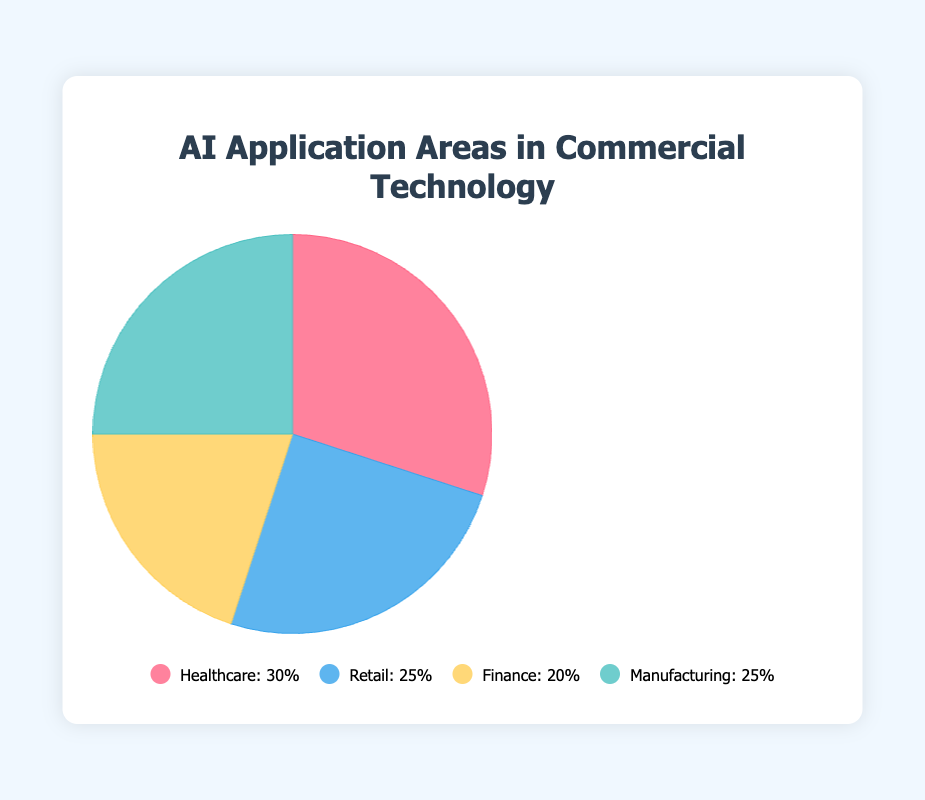Which AI application area has the highest percentage? The Healthcare category has the highest percentage at 30%. This is identified by looking at the label with the highest percentage in the pie chart.
Answer: Healthcare Which two AI application areas have an equal percentage? The Retail and Manufacturing categories both have a percentage of 25%. This can be identified by visually comparing the sizes of the segments in the pie chart and their corresponding percentages.
Answer: Retail and Manufacturing What is the difference in percentage between Healthcare and Finance? The Healthcare category has 30%, and the Finance category has 20%. The difference between these two values is calculated as 30% - 20% = 10%.
Answer: 10% What are the top two categories in terms of percentage? The top two categories are Healthcare with 30% and both Retail and Manufacturing with 25%. To identify the top two, look for the largest segments and their percentages.
Answer: Healthcare and Retail/Manufacturing What is the average percentage of all AI application areas? The percentages are 30% (Healthcare), 25% (Retail), 20% (Finance), and 25% (Manufacturing). Sum these values: 30 + 25 + 20 + 25 = 100. Then, divide by the number of categories (4): 100 / 4 = 25.
Answer: 25% Which category represents one-fifth of the total pie? The Finance category represents 20% of the pie which is equivalent to one-fifth. This can be confirmed by seeing that 20% is one-fifth of 100%.
Answer: Finance If the Retail percentage was increased by 10%, what would its new percentage be? The initial Retail percentage is 25%. Adding 10% to this value results in a new percentage of 25% + 10% = 35%.
Answer: 35% Which segment has the smallest visual representation? The Finance category has the smallest visual representation with 20%. This can be identified by comparing the relative sizes of the segments visually.
Answer: Finance Are there any segments that are visually equal in size? Yes, the Retail and Manufacturing segments are visually equal in size, each representing 25%. This is determined by comparing their respective segments in the pie chart.
Answer: Retail and Manufacturing 